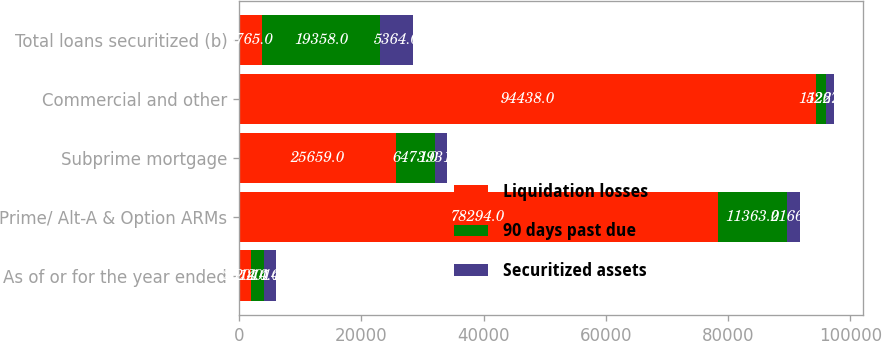Convert chart. <chart><loc_0><loc_0><loc_500><loc_500><stacked_bar_chart><ecel><fcel>As of or for the year ended<fcel>Prime/ Alt-A & Option ARMs<fcel>Subprime mortgage<fcel>Commercial and other<fcel>Total loans securitized (b)<nl><fcel>Liquidation losses<fcel>2014<fcel>78294<fcel>25659<fcel>94438<fcel>3765<nl><fcel>90 days past due<fcel>2014<fcel>11363<fcel>6473<fcel>1522<fcel>19358<nl><fcel>Securitized assets<fcel>2014<fcel>2166<fcel>1931<fcel>1267<fcel>5364<nl></chart> 